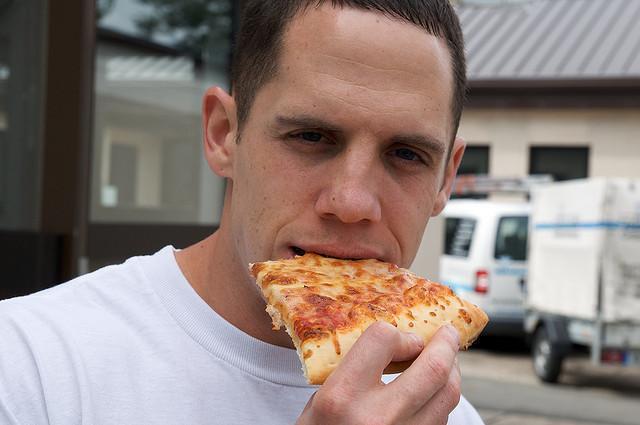Verify the accuracy of this image caption: "The person is touching the pizza.".
Answer yes or no. Yes. 